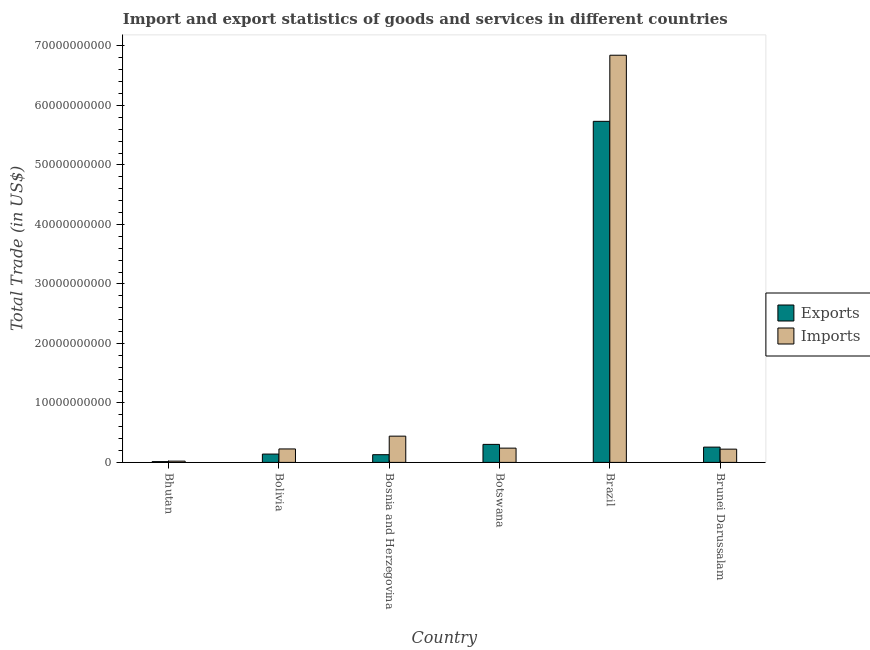How many different coloured bars are there?
Keep it short and to the point. 2. What is the export of goods and services in Bolivia?
Offer a very short reply. 1.40e+09. Across all countries, what is the maximum export of goods and services?
Your answer should be compact. 5.73e+1. Across all countries, what is the minimum imports of goods and services?
Your response must be concise. 2.12e+08. In which country was the imports of goods and services minimum?
Make the answer very short. Bhutan. What is the total imports of goods and services in the graph?
Provide a short and direct response. 8.00e+1. What is the difference between the export of goods and services in Bosnia and Herzegovina and that in Brazil?
Ensure brevity in your answer.  -5.60e+1. What is the difference between the imports of goods and services in Bolivia and the export of goods and services in Brazil?
Ensure brevity in your answer.  -5.51e+1. What is the average export of goods and services per country?
Your answer should be compact. 1.10e+1. What is the difference between the imports of goods and services and export of goods and services in Bhutan?
Your answer should be compact. 8.21e+07. What is the ratio of the export of goods and services in Bolivia to that in Brazil?
Give a very brief answer. 0.02. Is the export of goods and services in Bosnia and Herzegovina less than that in Brunei Darussalam?
Your answer should be very brief. Yes. What is the difference between the highest and the second highest export of goods and services?
Make the answer very short. 5.43e+1. What is the difference between the highest and the lowest export of goods and services?
Your answer should be compact. 5.72e+1. In how many countries, is the export of goods and services greater than the average export of goods and services taken over all countries?
Offer a terse response. 1. What does the 1st bar from the left in Bhutan represents?
Your answer should be compact. Exports. What does the 1st bar from the right in Brazil represents?
Keep it short and to the point. Imports. Are all the bars in the graph horizontal?
Provide a succinct answer. No. What is the difference between two consecutive major ticks on the Y-axis?
Offer a terse response. 1.00e+1. Does the graph contain any zero values?
Offer a terse response. No. Where does the legend appear in the graph?
Your answer should be compact. Center right. What is the title of the graph?
Offer a terse response. Import and export statistics of goods and services in different countries. Does "Adolescent fertility rate" appear as one of the legend labels in the graph?
Provide a succinct answer. No. What is the label or title of the X-axis?
Your answer should be compact. Country. What is the label or title of the Y-axis?
Your answer should be very brief. Total Trade (in US$). What is the Total Trade (in US$) of Exports in Bhutan?
Ensure brevity in your answer.  1.30e+08. What is the Total Trade (in US$) of Imports in Bhutan?
Offer a very short reply. 2.12e+08. What is the Total Trade (in US$) of Exports in Bolivia?
Keep it short and to the point. 1.40e+09. What is the Total Trade (in US$) in Imports in Bolivia?
Give a very brief answer. 2.26e+09. What is the Total Trade (in US$) in Exports in Bosnia and Herzegovina?
Your answer should be very brief. 1.30e+09. What is the Total Trade (in US$) of Imports in Bosnia and Herzegovina?
Your answer should be very brief. 4.41e+09. What is the Total Trade (in US$) in Exports in Botswana?
Offer a terse response. 3.03e+09. What is the Total Trade (in US$) in Imports in Botswana?
Offer a very short reply. 2.40e+09. What is the Total Trade (in US$) in Exports in Brazil?
Make the answer very short. 5.73e+1. What is the Total Trade (in US$) of Imports in Brazil?
Offer a very short reply. 6.84e+1. What is the Total Trade (in US$) in Exports in Brunei Darussalam?
Provide a short and direct response. 2.57e+09. What is the Total Trade (in US$) in Imports in Brunei Darussalam?
Ensure brevity in your answer.  2.23e+09. Across all countries, what is the maximum Total Trade (in US$) in Exports?
Provide a short and direct response. 5.73e+1. Across all countries, what is the maximum Total Trade (in US$) of Imports?
Provide a succinct answer. 6.84e+1. Across all countries, what is the minimum Total Trade (in US$) in Exports?
Make the answer very short. 1.30e+08. Across all countries, what is the minimum Total Trade (in US$) of Imports?
Your response must be concise. 2.12e+08. What is the total Total Trade (in US$) in Exports in the graph?
Ensure brevity in your answer.  6.57e+1. What is the total Total Trade (in US$) in Imports in the graph?
Your answer should be very brief. 8.00e+1. What is the difference between the Total Trade (in US$) of Exports in Bhutan and that in Bolivia?
Offer a terse response. -1.27e+09. What is the difference between the Total Trade (in US$) in Imports in Bhutan and that in Bolivia?
Ensure brevity in your answer.  -2.05e+09. What is the difference between the Total Trade (in US$) in Exports in Bhutan and that in Bosnia and Herzegovina?
Provide a short and direct response. -1.16e+09. What is the difference between the Total Trade (in US$) in Imports in Bhutan and that in Bosnia and Herzegovina?
Your answer should be compact. -4.20e+09. What is the difference between the Total Trade (in US$) of Exports in Bhutan and that in Botswana?
Your answer should be very brief. -2.90e+09. What is the difference between the Total Trade (in US$) in Imports in Bhutan and that in Botswana?
Keep it short and to the point. -2.19e+09. What is the difference between the Total Trade (in US$) in Exports in Bhutan and that in Brazil?
Make the answer very short. -5.72e+1. What is the difference between the Total Trade (in US$) in Imports in Bhutan and that in Brazil?
Offer a terse response. -6.82e+1. What is the difference between the Total Trade (in US$) of Exports in Bhutan and that in Brunei Darussalam?
Your answer should be very brief. -2.44e+09. What is the difference between the Total Trade (in US$) in Imports in Bhutan and that in Brunei Darussalam?
Keep it short and to the point. -2.01e+09. What is the difference between the Total Trade (in US$) of Exports in Bolivia and that in Bosnia and Herzegovina?
Your answer should be very brief. 1.03e+08. What is the difference between the Total Trade (in US$) in Imports in Bolivia and that in Bosnia and Herzegovina?
Offer a terse response. -2.15e+09. What is the difference between the Total Trade (in US$) of Exports in Bolivia and that in Botswana?
Your answer should be compact. -1.63e+09. What is the difference between the Total Trade (in US$) of Imports in Bolivia and that in Botswana?
Your answer should be very brief. -1.38e+08. What is the difference between the Total Trade (in US$) of Exports in Bolivia and that in Brazil?
Offer a very short reply. -5.59e+1. What is the difference between the Total Trade (in US$) of Imports in Bolivia and that in Brazil?
Your answer should be very brief. -6.62e+1. What is the difference between the Total Trade (in US$) of Exports in Bolivia and that in Brunei Darussalam?
Make the answer very short. -1.17e+09. What is the difference between the Total Trade (in US$) of Imports in Bolivia and that in Brunei Darussalam?
Your answer should be compact. 3.42e+07. What is the difference between the Total Trade (in US$) of Exports in Bosnia and Herzegovina and that in Botswana?
Keep it short and to the point. -1.73e+09. What is the difference between the Total Trade (in US$) of Imports in Bosnia and Herzegovina and that in Botswana?
Provide a short and direct response. 2.01e+09. What is the difference between the Total Trade (in US$) of Exports in Bosnia and Herzegovina and that in Brazil?
Offer a very short reply. -5.60e+1. What is the difference between the Total Trade (in US$) in Imports in Bosnia and Herzegovina and that in Brazil?
Ensure brevity in your answer.  -6.40e+1. What is the difference between the Total Trade (in US$) of Exports in Bosnia and Herzegovina and that in Brunei Darussalam?
Make the answer very short. -1.27e+09. What is the difference between the Total Trade (in US$) of Imports in Bosnia and Herzegovina and that in Brunei Darussalam?
Ensure brevity in your answer.  2.19e+09. What is the difference between the Total Trade (in US$) in Exports in Botswana and that in Brazil?
Provide a succinct answer. -5.43e+1. What is the difference between the Total Trade (in US$) in Imports in Botswana and that in Brazil?
Offer a terse response. -6.60e+1. What is the difference between the Total Trade (in US$) in Exports in Botswana and that in Brunei Darussalam?
Make the answer very short. 4.60e+08. What is the difference between the Total Trade (in US$) of Imports in Botswana and that in Brunei Darussalam?
Give a very brief answer. 1.72e+08. What is the difference between the Total Trade (in US$) of Exports in Brazil and that in Brunei Darussalam?
Ensure brevity in your answer.  5.48e+1. What is the difference between the Total Trade (in US$) of Imports in Brazil and that in Brunei Darussalam?
Make the answer very short. 6.62e+1. What is the difference between the Total Trade (in US$) of Exports in Bhutan and the Total Trade (in US$) of Imports in Bolivia?
Ensure brevity in your answer.  -2.13e+09. What is the difference between the Total Trade (in US$) of Exports in Bhutan and the Total Trade (in US$) of Imports in Bosnia and Herzegovina?
Offer a very short reply. -4.28e+09. What is the difference between the Total Trade (in US$) of Exports in Bhutan and the Total Trade (in US$) of Imports in Botswana?
Make the answer very short. -2.27e+09. What is the difference between the Total Trade (in US$) in Exports in Bhutan and the Total Trade (in US$) in Imports in Brazil?
Your response must be concise. -6.83e+1. What is the difference between the Total Trade (in US$) in Exports in Bhutan and the Total Trade (in US$) in Imports in Brunei Darussalam?
Make the answer very short. -2.10e+09. What is the difference between the Total Trade (in US$) in Exports in Bolivia and the Total Trade (in US$) in Imports in Bosnia and Herzegovina?
Provide a short and direct response. -3.01e+09. What is the difference between the Total Trade (in US$) in Exports in Bolivia and the Total Trade (in US$) in Imports in Botswana?
Your answer should be very brief. -1.00e+09. What is the difference between the Total Trade (in US$) in Exports in Bolivia and the Total Trade (in US$) in Imports in Brazil?
Your answer should be very brief. -6.70e+1. What is the difference between the Total Trade (in US$) of Exports in Bolivia and the Total Trade (in US$) of Imports in Brunei Darussalam?
Keep it short and to the point. -8.28e+08. What is the difference between the Total Trade (in US$) in Exports in Bosnia and Herzegovina and the Total Trade (in US$) in Imports in Botswana?
Provide a short and direct response. -1.10e+09. What is the difference between the Total Trade (in US$) in Exports in Bosnia and Herzegovina and the Total Trade (in US$) in Imports in Brazil?
Give a very brief answer. -6.71e+1. What is the difference between the Total Trade (in US$) in Exports in Bosnia and Herzegovina and the Total Trade (in US$) in Imports in Brunei Darussalam?
Provide a short and direct response. -9.31e+08. What is the difference between the Total Trade (in US$) of Exports in Botswana and the Total Trade (in US$) of Imports in Brazil?
Provide a short and direct response. -6.54e+1. What is the difference between the Total Trade (in US$) of Exports in Botswana and the Total Trade (in US$) of Imports in Brunei Darussalam?
Ensure brevity in your answer.  8.01e+08. What is the difference between the Total Trade (in US$) of Exports in Brazil and the Total Trade (in US$) of Imports in Brunei Darussalam?
Make the answer very short. 5.51e+1. What is the average Total Trade (in US$) in Exports per country?
Provide a short and direct response. 1.10e+1. What is the average Total Trade (in US$) in Imports per country?
Offer a very short reply. 1.33e+1. What is the difference between the Total Trade (in US$) of Exports and Total Trade (in US$) of Imports in Bhutan?
Make the answer very short. -8.21e+07. What is the difference between the Total Trade (in US$) of Exports and Total Trade (in US$) of Imports in Bolivia?
Provide a succinct answer. -8.62e+08. What is the difference between the Total Trade (in US$) of Exports and Total Trade (in US$) of Imports in Bosnia and Herzegovina?
Offer a very short reply. -3.12e+09. What is the difference between the Total Trade (in US$) in Exports and Total Trade (in US$) in Imports in Botswana?
Provide a succinct answer. 6.29e+08. What is the difference between the Total Trade (in US$) of Exports and Total Trade (in US$) of Imports in Brazil?
Offer a very short reply. -1.11e+1. What is the difference between the Total Trade (in US$) of Exports and Total Trade (in US$) of Imports in Brunei Darussalam?
Your answer should be compact. 3.41e+08. What is the ratio of the Total Trade (in US$) in Exports in Bhutan to that in Bolivia?
Make the answer very short. 0.09. What is the ratio of the Total Trade (in US$) in Imports in Bhutan to that in Bolivia?
Your answer should be compact. 0.09. What is the ratio of the Total Trade (in US$) of Exports in Bhutan to that in Bosnia and Herzegovina?
Provide a short and direct response. 0.1. What is the ratio of the Total Trade (in US$) of Imports in Bhutan to that in Bosnia and Herzegovina?
Your answer should be very brief. 0.05. What is the ratio of the Total Trade (in US$) of Exports in Bhutan to that in Botswana?
Your answer should be compact. 0.04. What is the ratio of the Total Trade (in US$) in Imports in Bhutan to that in Botswana?
Make the answer very short. 0.09. What is the ratio of the Total Trade (in US$) of Exports in Bhutan to that in Brazil?
Make the answer very short. 0. What is the ratio of the Total Trade (in US$) of Imports in Bhutan to that in Brazil?
Make the answer very short. 0. What is the ratio of the Total Trade (in US$) in Exports in Bhutan to that in Brunei Darussalam?
Provide a succinct answer. 0.05. What is the ratio of the Total Trade (in US$) in Imports in Bhutan to that in Brunei Darussalam?
Provide a succinct answer. 0.1. What is the ratio of the Total Trade (in US$) in Exports in Bolivia to that in Bosnia and Herzegovina?
Your response must be concise. 1.08. What is the ratio of the Total Trade (in US$) in Imports in Bolivia to that in Bosnia and Herzegovina?
Offer a very short reply. 0.51. What is the ratio of the Total Trade (in US$) of Exports in Bolivia to that in Botswana?
Ensure brevity in your answer.  0.46. What is the ratio of the Total Trade (in US$) of Imports in Bolivia to that in Botswana?
Your answer should be compact. 0.94. What is the ratio of the Total Trade (in US$) of Exports in Bolivia to that in Brazil?
Offer a terse response. 0.02. What is the ratio of the Total Trade (in US$) in Imports in Bolivia to that in Brazil?
Ensure brevity in your answer.  0.03. What is the ratio of the Total Trade (in US$) of Exports in Bolivia to that in Brunei Darussalam?
Provide a short and direct response. 0.54. What is the ratio of the Total Trade (in US$) in Imports in Bolivia to that in Brunei Darussalam?
Keep it short and to the point. 1.02. What is the ratio of the Total Trade (in US$) in Exports in Bosnia and Herzegovina to that in Botswana?
Give a very brief answer. 0.43. What is the ratio of the Total Trade (in US$) in Imports in Bosnia and Herzegovina to that in Botswana?
Your response must be concise. 1.84. What is the ratio of the Total Trade (in US$) in Exports in Bosnia and Herzegovina to that in Brazil?
Your response must be concise. 0.02. What is the ratio of the Total Trade (in US$) of Imports in Bosnia and Herzegovina to that in Brazil?
Make the answer very short. 0.06. What is the ratio of the Total Trade (in US$) in Exports in Bosnia and Herzegovina to that in Brunei Darussalam?
Ensure brevity in your answer.  0.5. What is the ratio of the Total Trade (in US$) of Imports in Bosnia and Herzegovina to that in Brunei Darussalam?
Your response must be concise. 1.98. What is the ratio of the Total Trade (in US$) of Exports in Botswana to that in Brazil?
Provide a short and direct response. 0.05. What is the ratio of the Total Trade (in US$) in Imports in Botswana to that in Brazil?
Provide a short and direct response. 0.04. What is the ratio of the Total Trade (in US$) of Exports in Botswana to that in Brunei Darussalam?
Make the answer very short. 1.18. What is the ratio of the Total Trade (in US$) in Imports in Botswana to that in Brunei Darussalam?
Your response must be concise. 1.08. What is the ratio of the Total Trade (in US$) in Exports in Brazil to that in Brunei Darussalam?
Your answer should be compact. 22.33. What is the ratio of the Total Trade (in US$) in Imports in Brazil to that in Brunei Darussalam?
Ensure brevity in your answer.  30.74. What is the difference between the highest and the second highest Total Trade (in US$) in Exports?
Provide a short and direct response. 5.43e+1. What is the difference between the highest and the second highest Total Trade (in US$) in Imports?
Your answer should be compact. 6.40e+1. What is the difference between the highest and the lowest Total Trade (in US$) of Exports?
Your response must be concise. 5.72e+1. What is the difference between the highest and the lowest Total Trade (in US$) in Imports?
Your answer should be compact. 6.82e+1. 